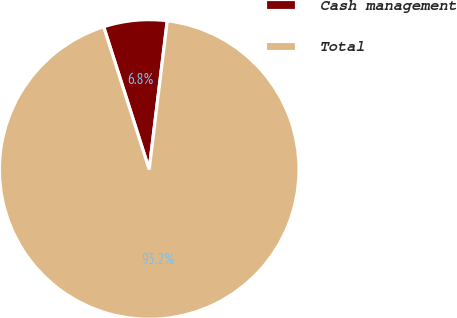Convert chart. <chart><loc_0><loc_0><loc_500><loc_500><pie_chart><fcel>Cash management<fcel>Total<nl><fcel>6.84%<fcel>93.16%<nl></chart> 